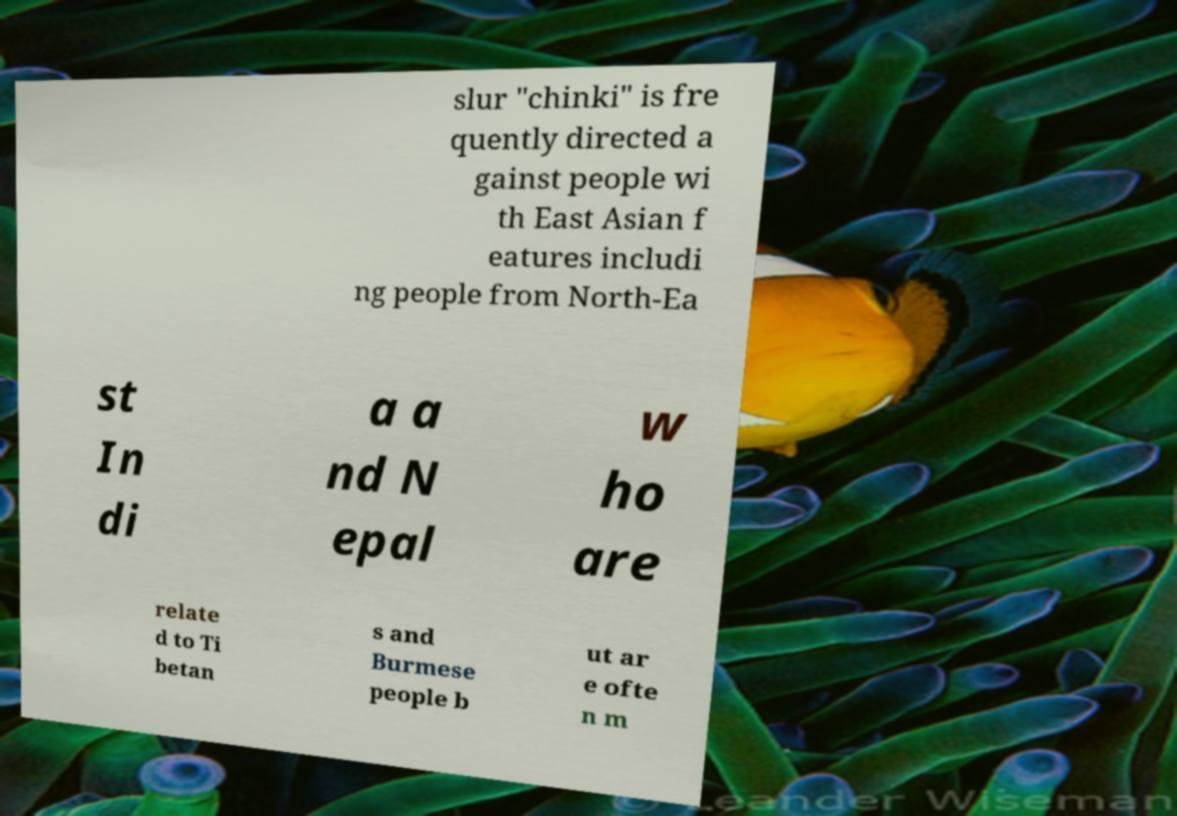Can you accurately transcribe the text from the provided image for me? slur "chinki" is fre quently directed a gainst people wi th East Asian f eatures includi ng people from North-Ea st In di a a nd N epal w ho are relate d to Ti betan s and Burmese people b ut ar e ofte n m 